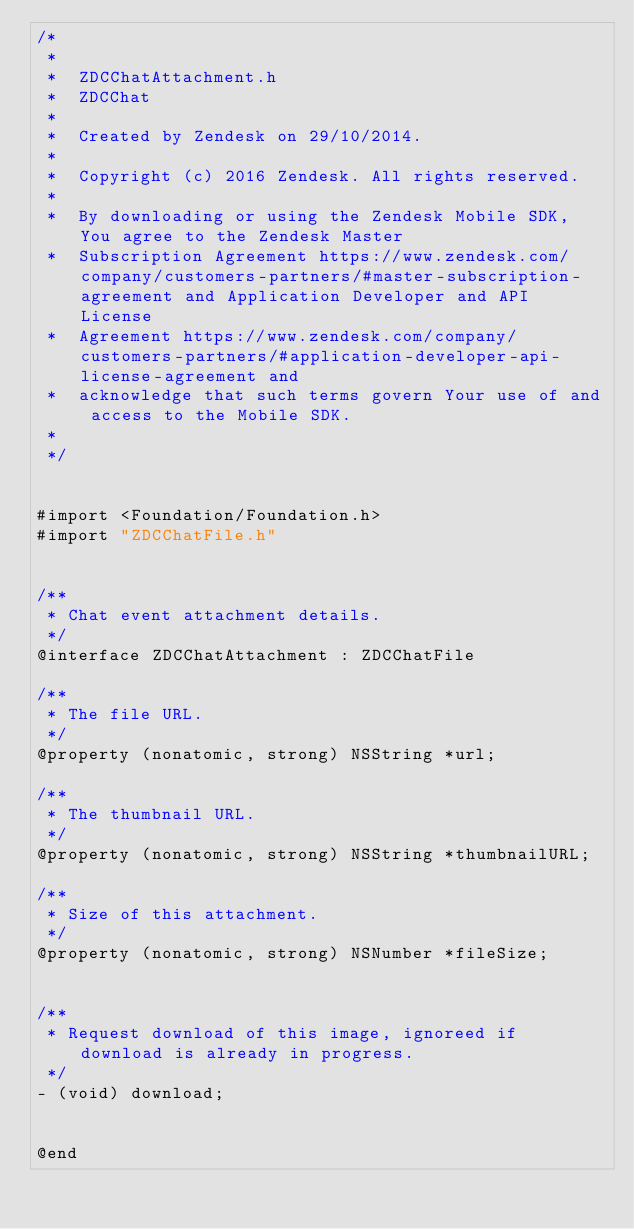<code> <loc_0><loc_0><loc_500><loc_500><_C_>/*
 *
 *  ZDCChatAttachment.h
 *  ZDCChat
 *
 *  Created by Zendesk on 29/10/2014.
 *
 *  Copyright (c) 2016 Zendesk. All rights reserved.
 *
 *  By downloading or using the Zendesk Mobile SDK, You agree to the Zendesk Master
 *  Subscription Agreement https://www.zendesk.com/company/customers-partners/#master-subscription-agreement and Application Developer and API License
 *  Agreement https://www.zendesk.com/company/customers-partners/#application-developer-api-license-agreement and
 *  acknowledge that such terms govern Your use of and access to the Mobile SDK.
 *
 */


#import <Foundation/Foundation.h>
#import "ZDCChatFile.h"


/**
 * Chat event attachment details.
 */
@interface ZDCChatAttachment : ZDCChatFile

/**
 * The file URL.
 */
@property (nonatomic, strong) NSString *url;

/**
 * The thumbnail URL.
 */
@property (nonatomic, strong) NSString *thumbnailURL;

/**
 * Size of this attachment.
 */
@property (nonatomic, strong) NSNumber *fileSize;


/**
 * Request download of this image, ignoreed if download is already in progress.
 */
- (void) download;


@end

</code> 